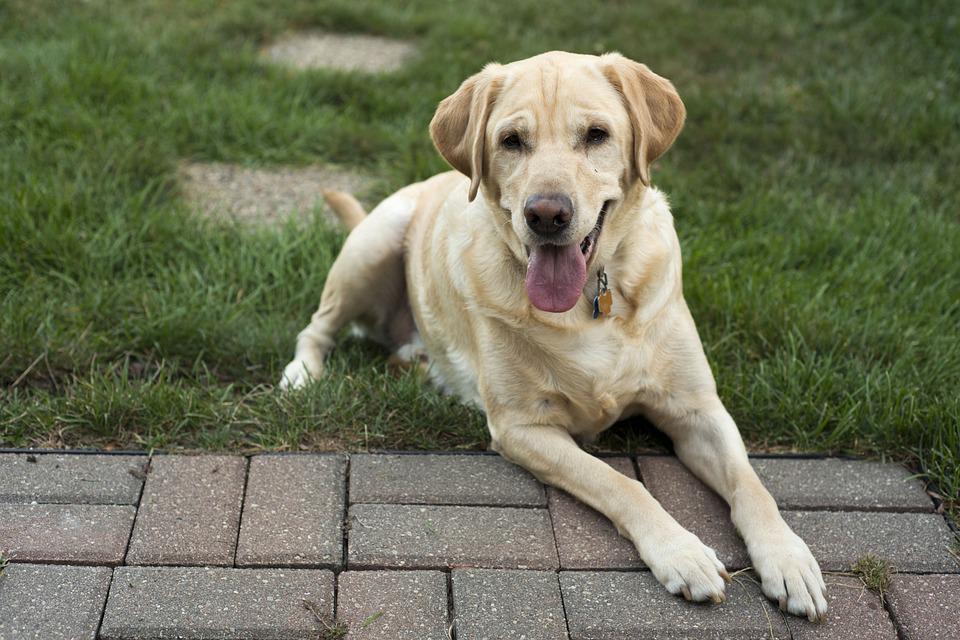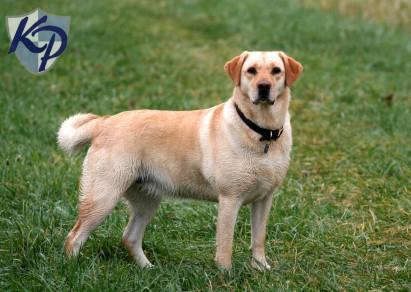The first image is the image on the left, the second image is the image on the right. Assess this claim about the two images: "One dog has at least two paws on cement.". Correct or not? Answer yes or no. Yes. 